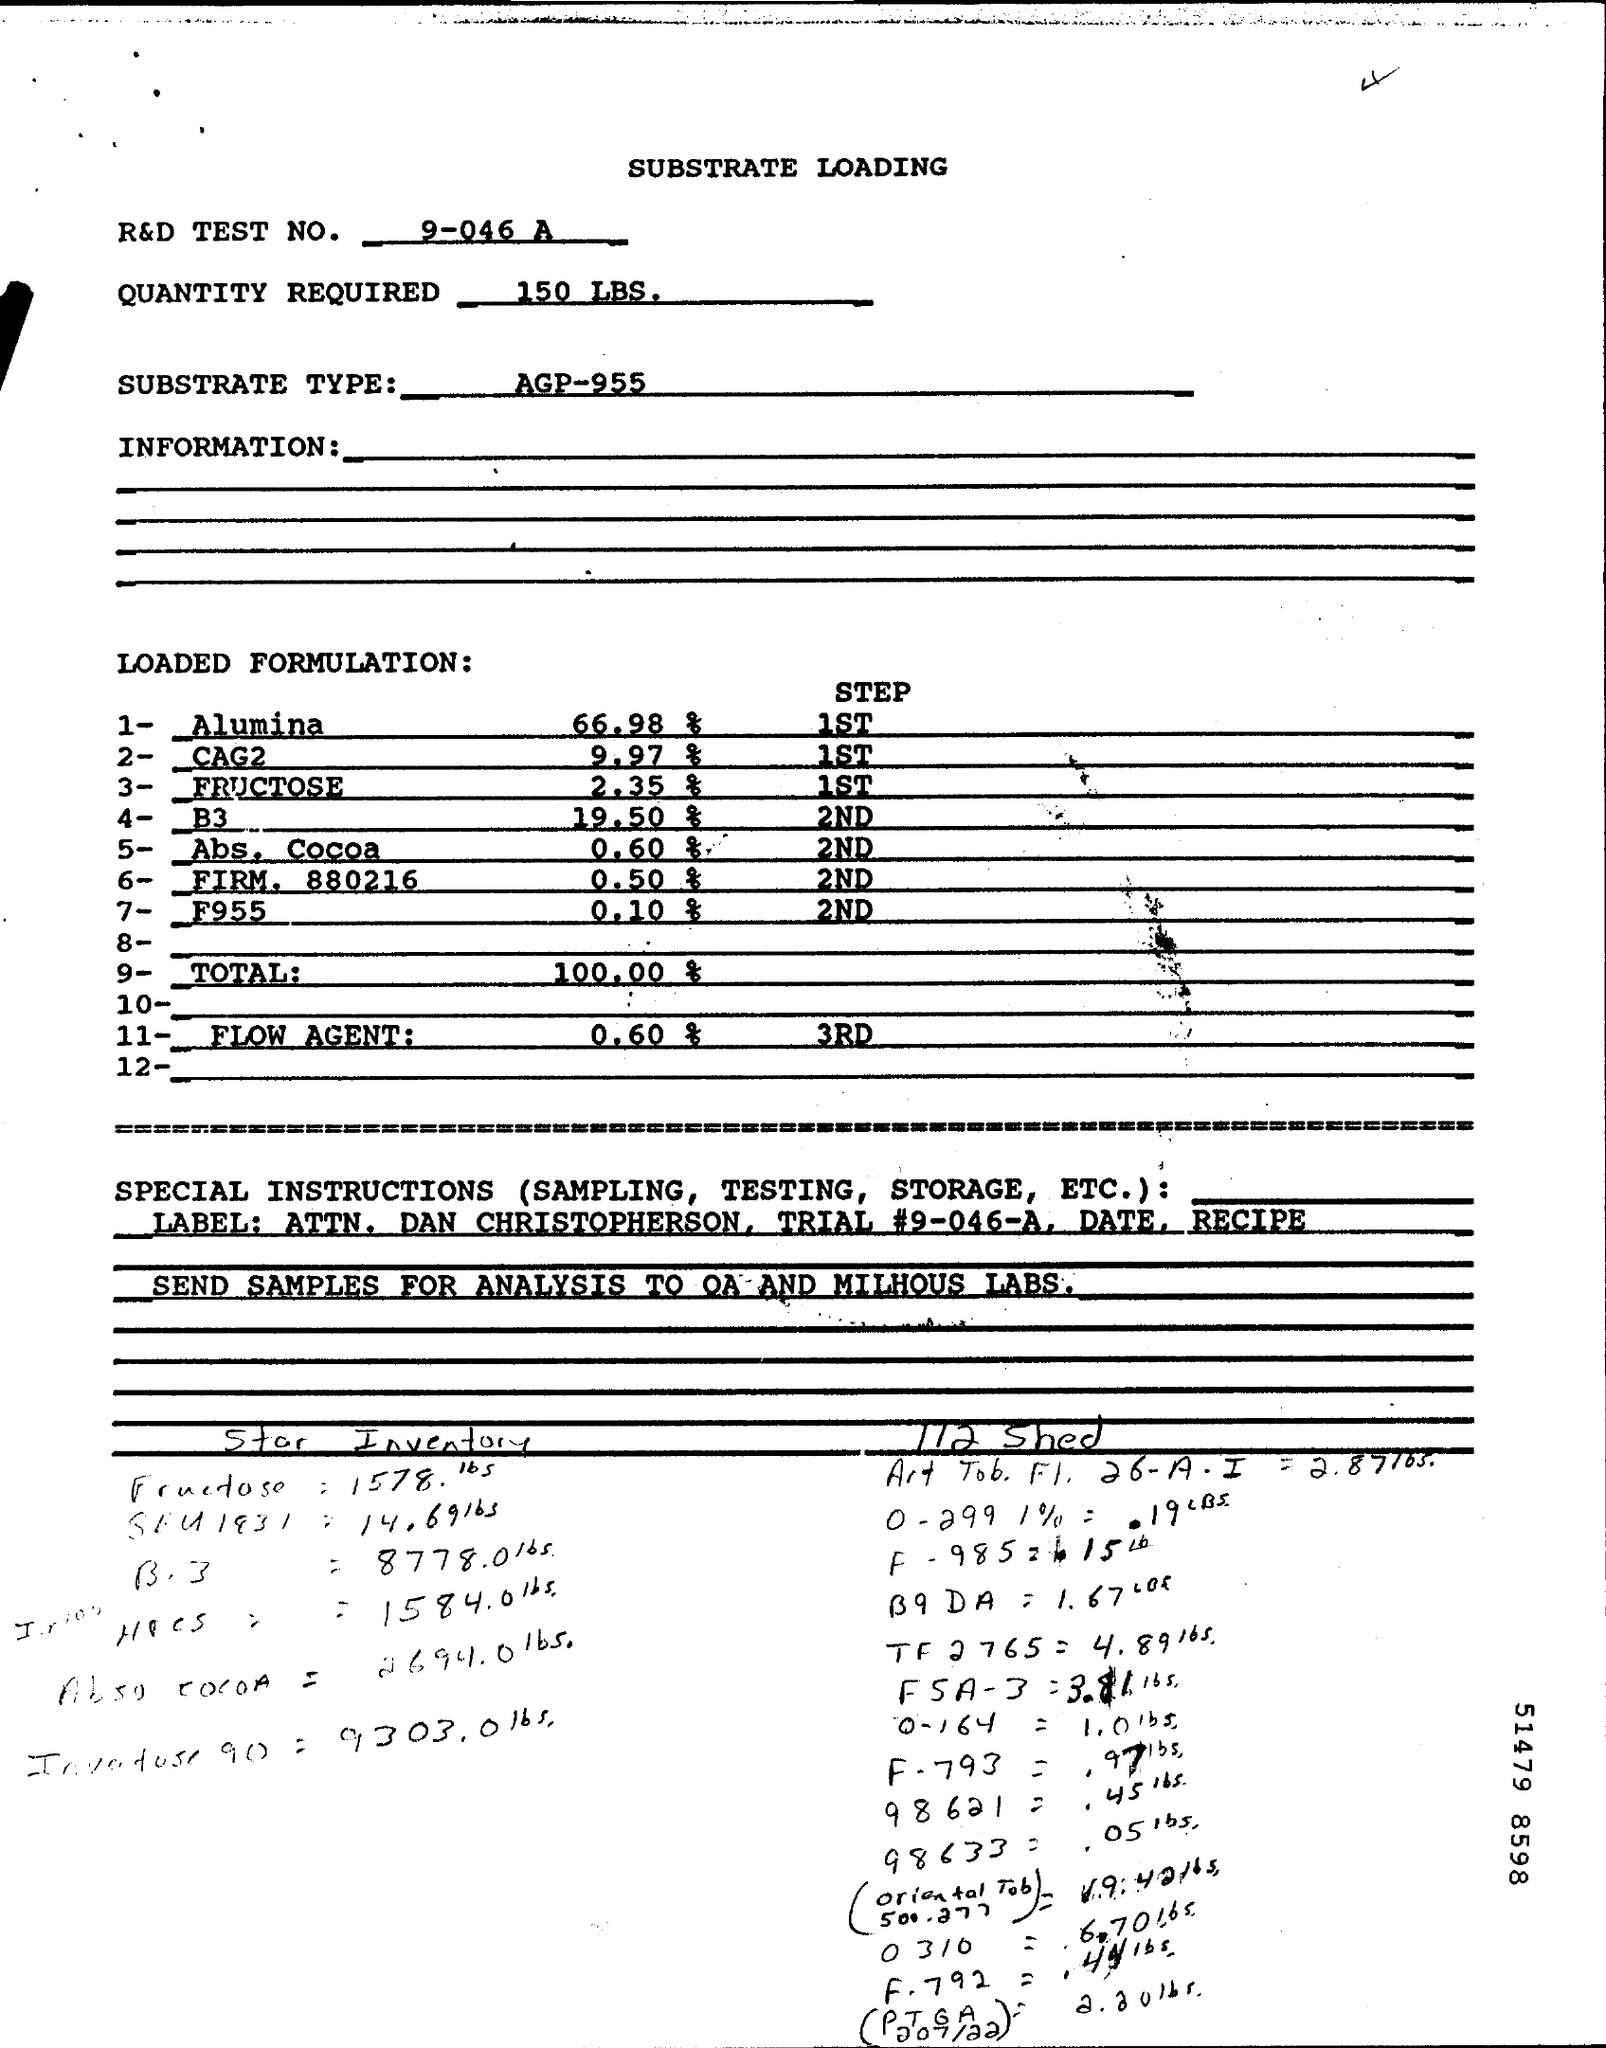What is substrate type?
Provide a short and direct response. AGP-955. 